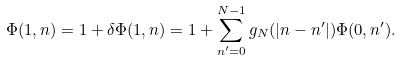<formula> <loc_0><loc_0><loc_500><loc_500>\Phi ( 1 , n ) = 1 + \delta \Phi ( 1 , n ) = 1 + \sum _ { n ^ { \prime } = 0 } ^ { N - 1 } g _ { N } ( | n - n ^ { \prime } | ) \Phi ( 0 , n ^ { \prime } ) .</formula> 